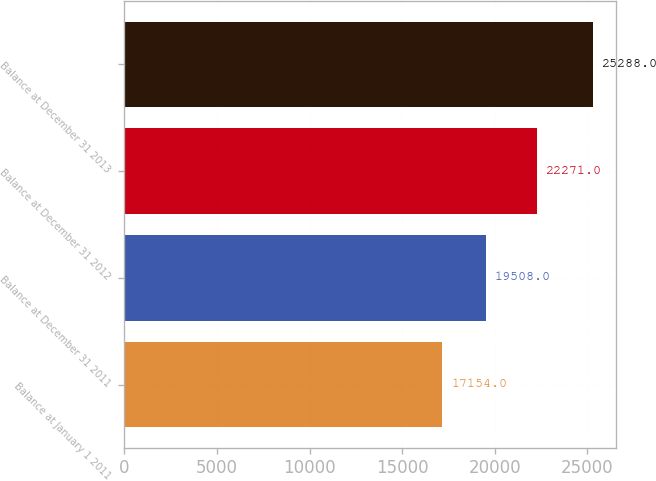Convert chart to OTSL. <chart><loc_0><loc_0><loc_500><loc_500><bar_chart><fcel>Balance at January 1 2011<fcel>Balance at December 31 2011<fcel>Balance at December 31 2012<fcel>Balance at December 31 2013<nl><fcel>17154<fcel>19508<fcel>22271<fcel>25288<nl></chart> 